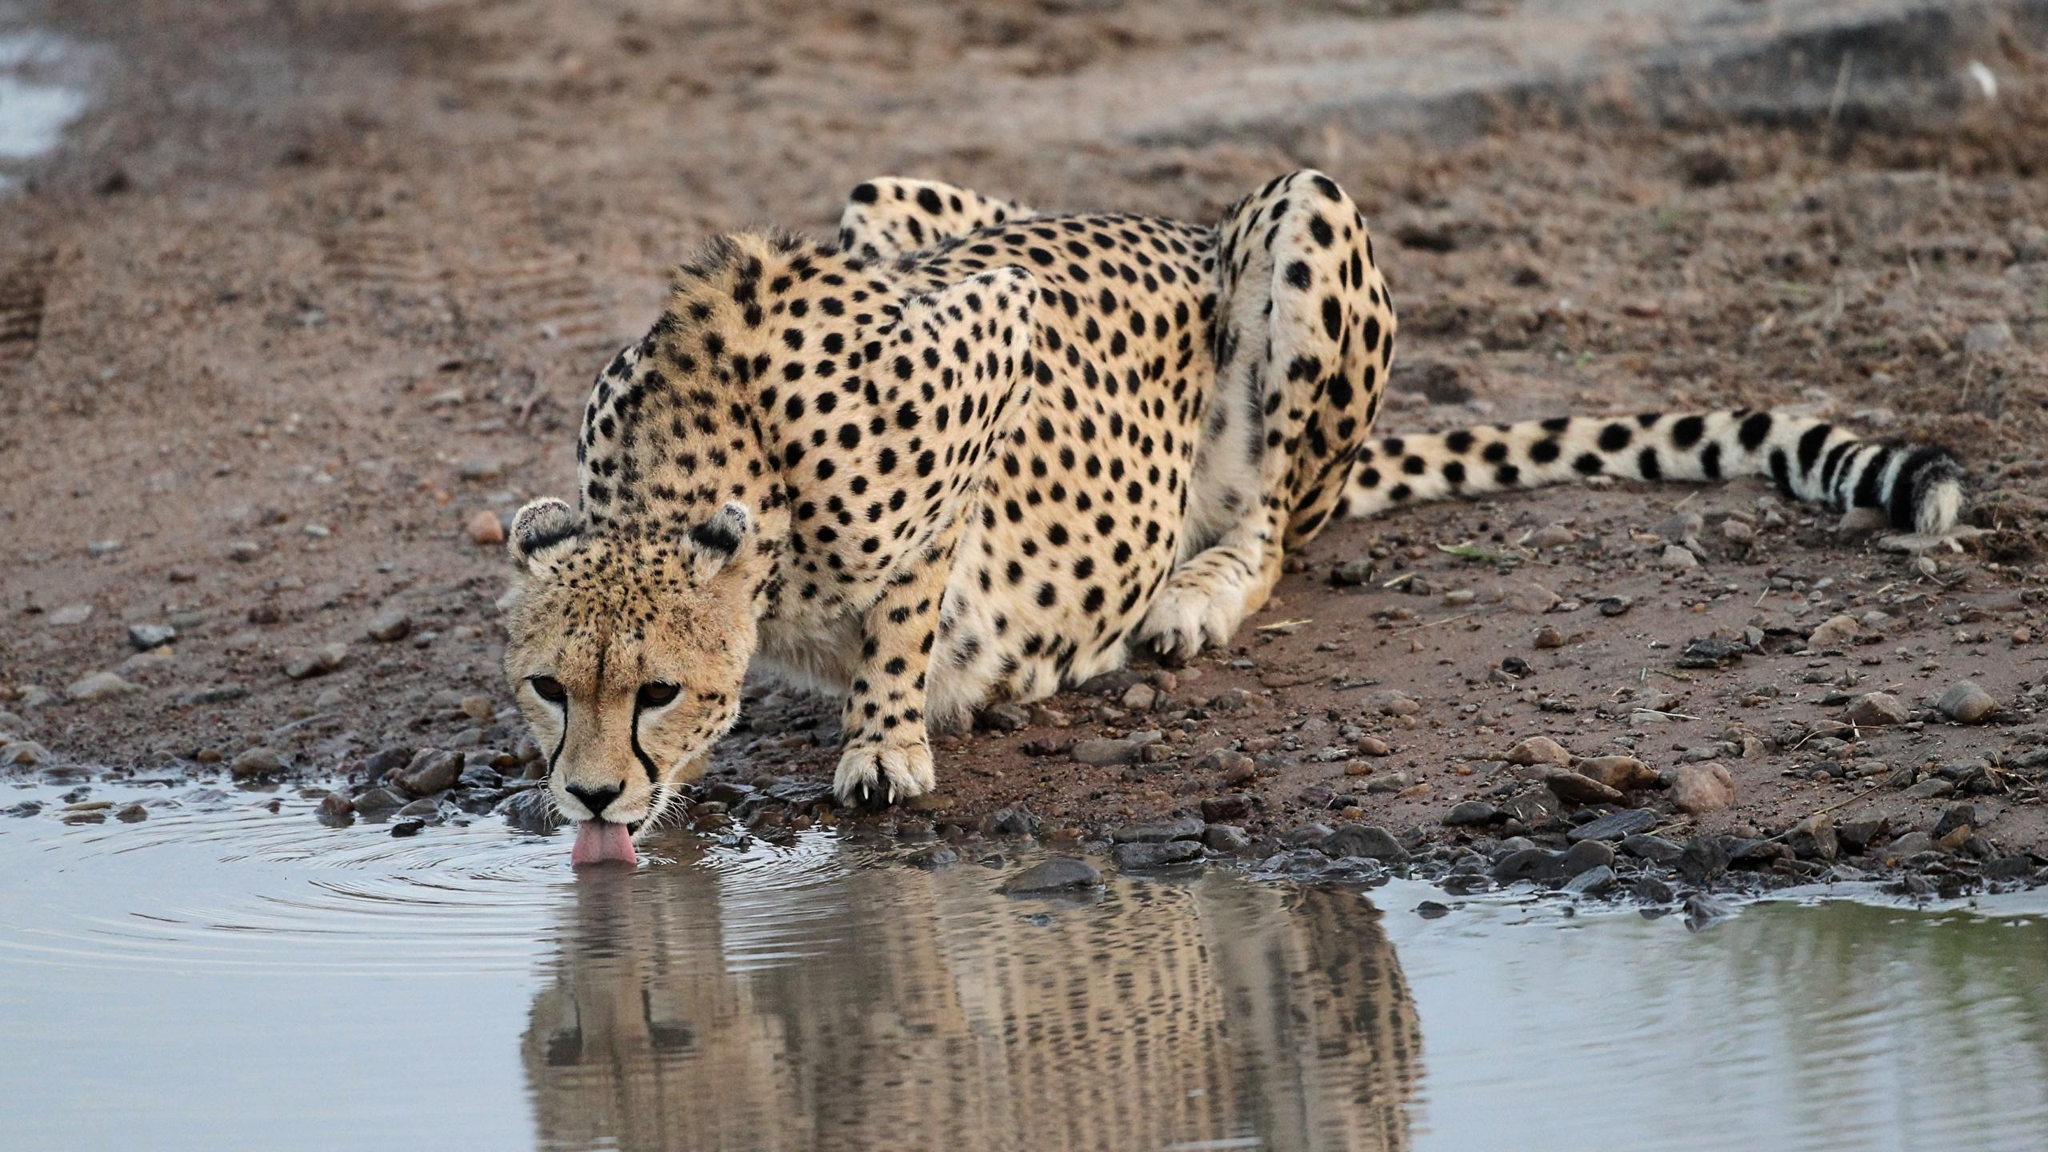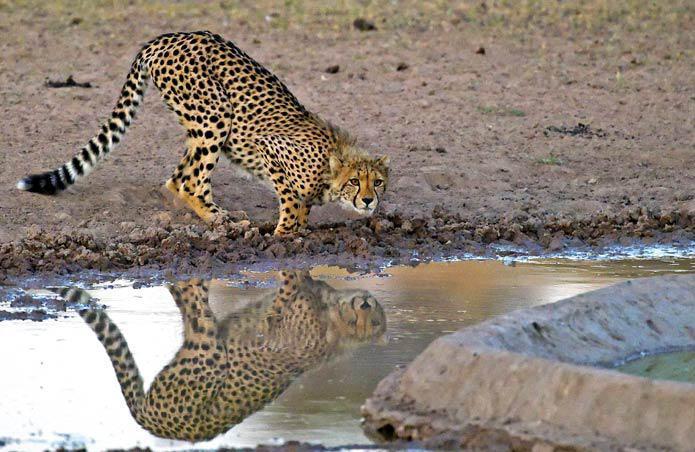The first image is the image on the left, the second image is the image on the right. Evaluate the accuracy of this statement regarding the images: "Each image features one spotted wildcat and a body of water, and in one image, the cat is actually drinking at the edge of the water.". Is it true? Answer yes or no. Yes. The first image is the image on the left, the second image is the image on the right. Evaluate the accuracy of this statement regarding the images: "The left image contains one cheetah standing on the bank of a lake drinking water.". Is it true? Answer yes or no. Yes. 